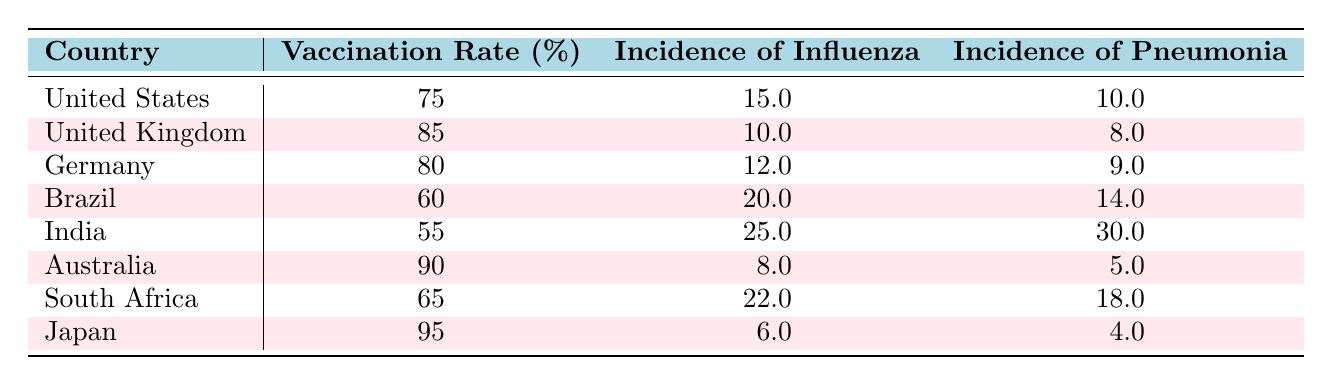What is the vaccination rate in Japan? Referring to the table, the vaccination rate for Japan is clearly listed in the second column next to Japan.
Answer: 95 Which country has the highest incidence of pneumonia? The incidence of pneumonia for each country is found in the third column. By comparing these values, India has the highest incidence at 30.
Answer: India What is the difference in vaccination rates between Australia and Brazil? The vaccination rate for Australia is 90, while for Brazil it is 60. The difference is calculated as 90 - 60 = 30.
Answer: 30 Are vaccination rates and incidence of influenza correlated in the displayed populations? A general observation shows that as vaccination rates increase, the incidence of influenza tends to decrease. For example, Japan with 95% vaccination has an incidence of 6, while Brazil with 60% has 20.
Answer: Yes What is the average incidence of influenza across all countries? To find the average, sum all incidence values (15 + 10 + 12 + 20 + 25 + 8 + 22 + 6 = 118) and divide by the number of countries (8). Thus, 118 / 8 = 14.75.
Answer: 14.75 Which country has a vaccination rate below 70% and what is its incidence of influenza? Looking at the vaccination rate column, Brazil (60%) and India (55%) meet the criteria. Their incidences of influenza are 20 and 25, respectively.
Answer: Brazil: 20, India: 25 Is the incidence of pneumonia in the United Kingdom lower than in the South Africa? The incidence of pneumonia in the UK is 8, whereas in South Africa, it is 18. Therefore, the statement is true.
Answer: Yes What is the total incidence of influenza for countries with vaccination rates above 80%? The countries with vaccination rates above 80% are the UK (10), Germany (12), Australia (8), and Japan (6). Summing those values gives: 10 + 12 + 8 + 6 = 36.
Answer: 36 What percentage of the countries listed have a vaccination rate of 70% or higher? There are 8 countries total. The countries with vaccination rates of 70% or higher are the US, UK, Germany, Australia, and Japan, which makes 5 countries. The percentage is (5/8) * 100 = 62.5%.
Answer: 62.5% 